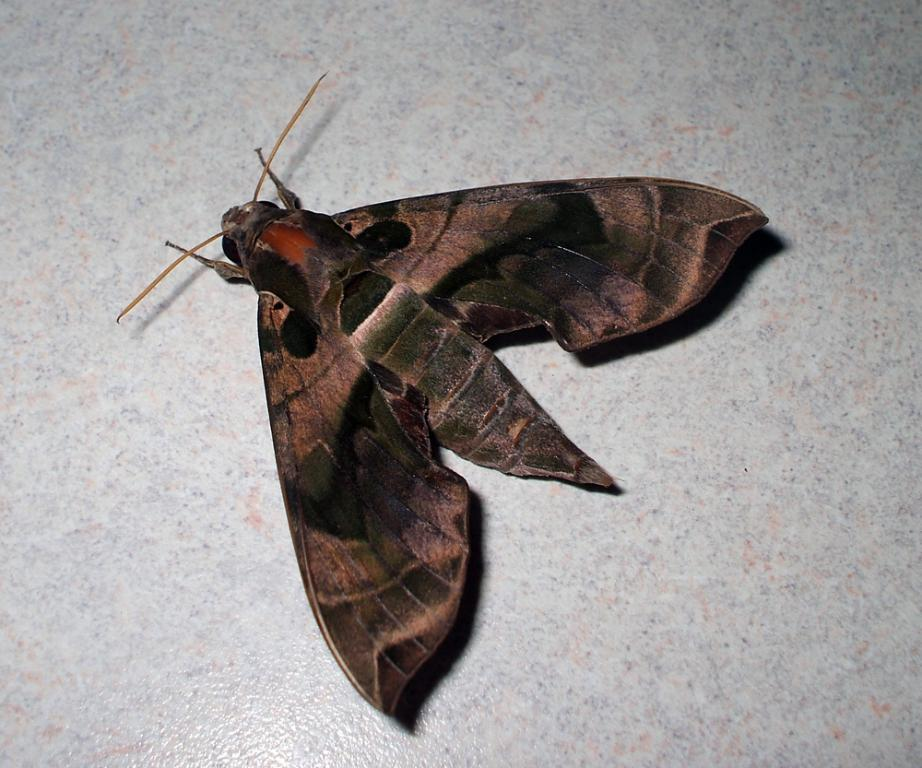What type of creature is in the image? There is an insect in the image. What feature does the insect have? The insect has wings. Where is the insect located in the image? The insect is sitting on the white floor. What is the price of the liquid in the image? There is no liquid present in the image, so it is not possible to determine a price. 